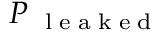<formula> <loc_0><loc_0><loc_500><loc_500>P _ { l e a k e d }</formula> 